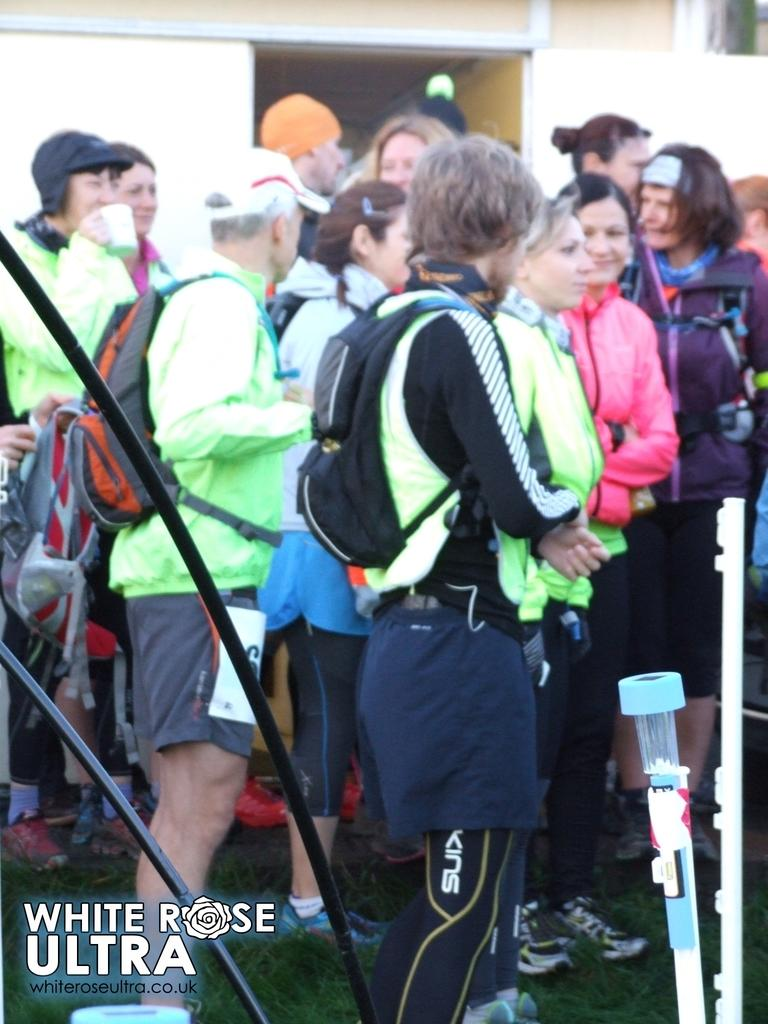Who or what can be seen in the image? There are people in the image. What type of surface is at the bottom of the image? There is grass at the bottom of the image. What objects are present in the image that resemble long, thin cylinders? There are tubes in the image. What type of structure can be seen in the distance in the image? There is a building in the background of the image. What type of wood can be seen in the image? There is no wood present in the image. How many nets are visible in the image? There are no nets visible in the image. 